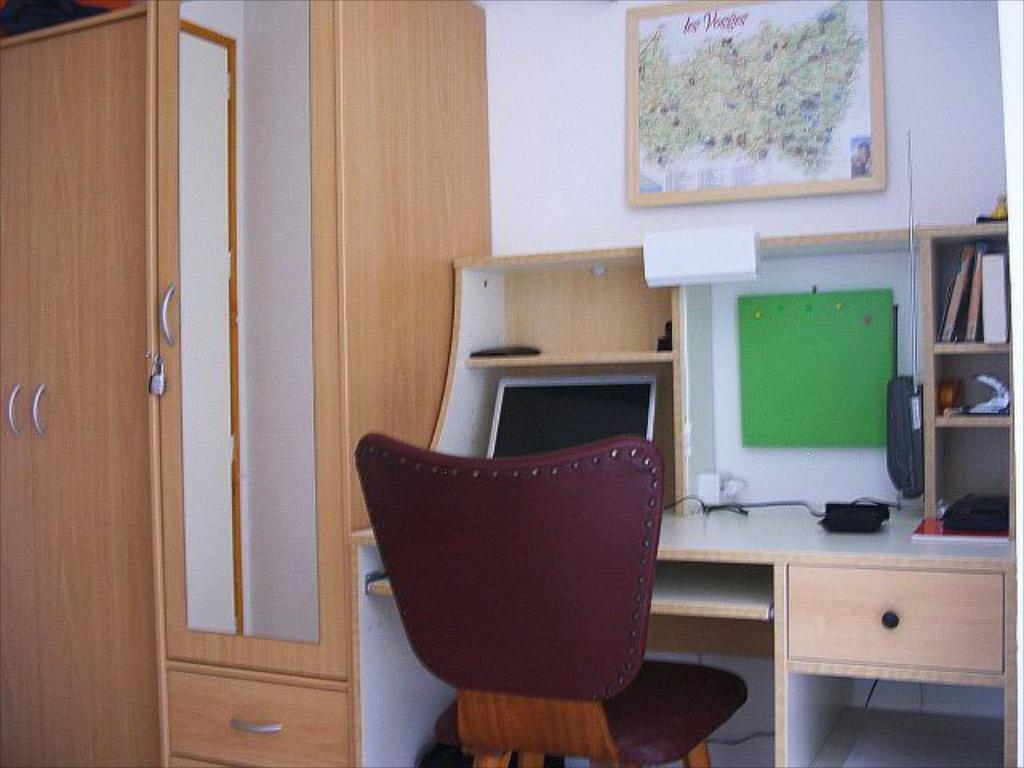In one or two sentences, can you explain what this image depicts? In the image wee can see there is a chair and in front of it there is a table on which there is a monitor and on the wall there is a photo frame of a world map and beside it there is a wardrobe. 